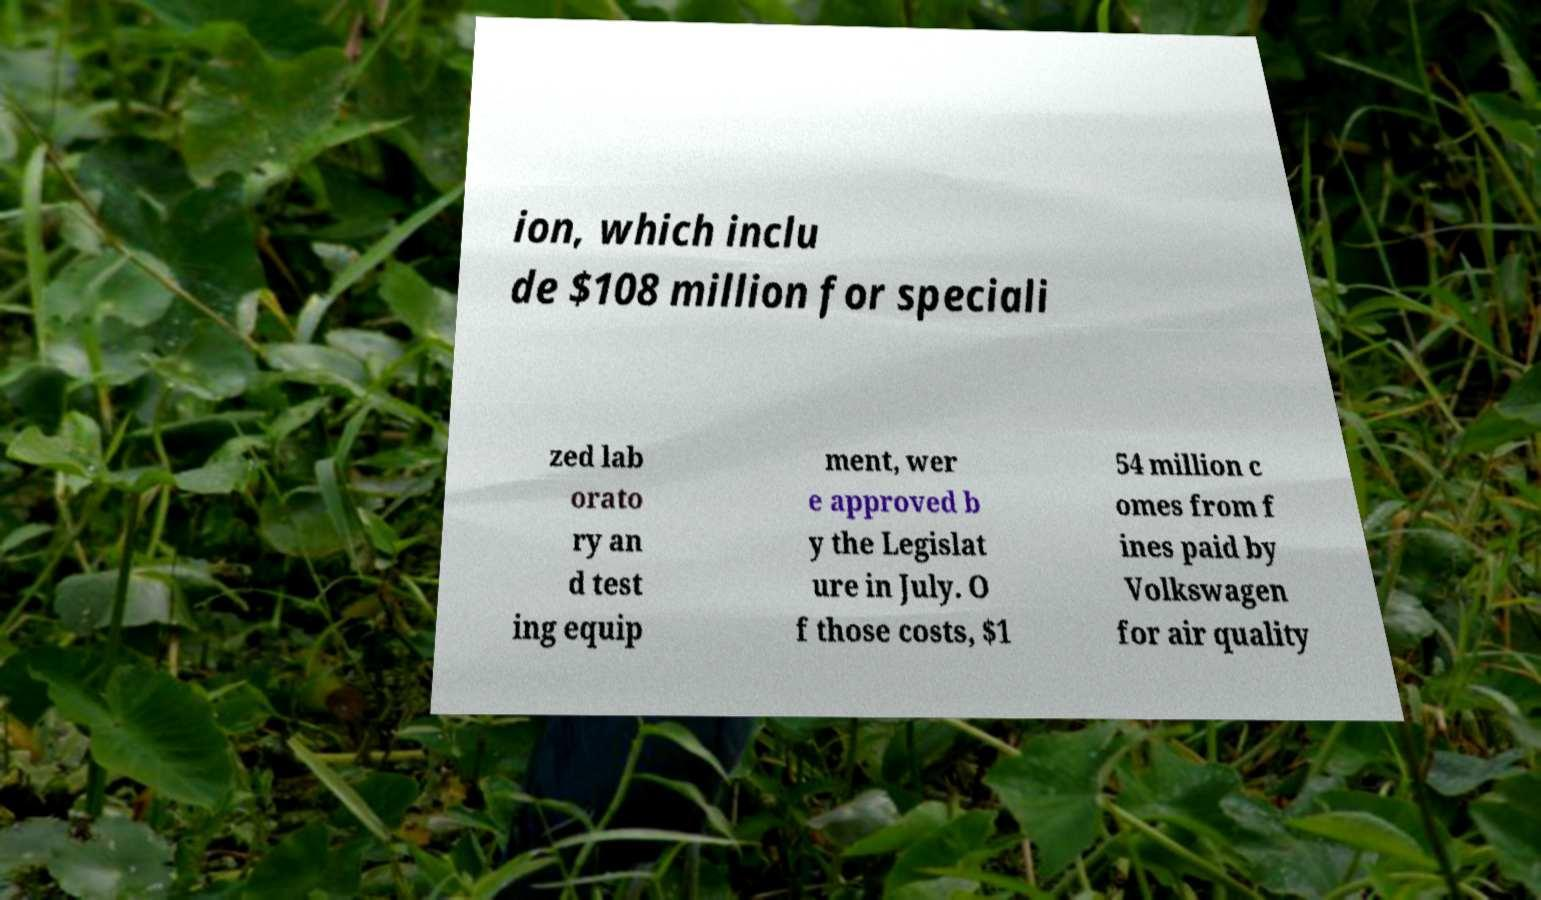Can you accurately transcribe the text from the provided image for me? ion, which inclu de $108 million for speciali zed lab orato ry an d test ing equip ment, wer e approved b y the Legislat ure in July. O f those costs, $1 54 million c omes from f ines paid by Volkswagen for air quality 